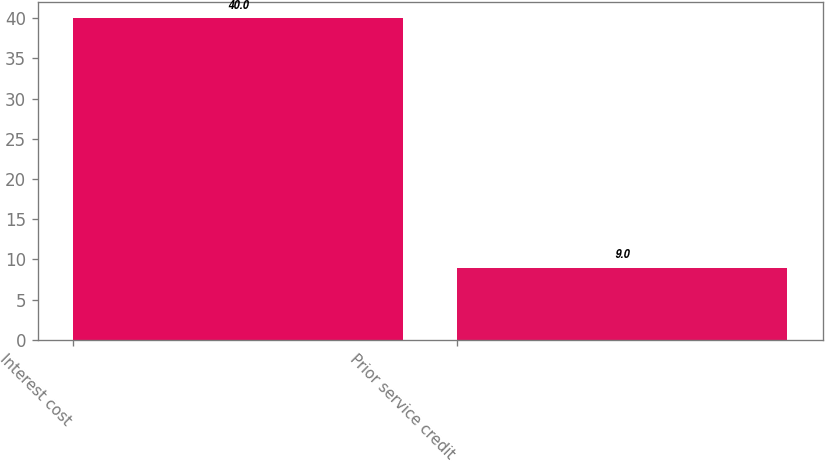Convert chart. <chart><loc_0><loc_0><loc_500><loc_500><bar_chart><fcel>Interest cost<fcel>Prior service credit<nl><fcel>40<fcel>9<nl></chart> 